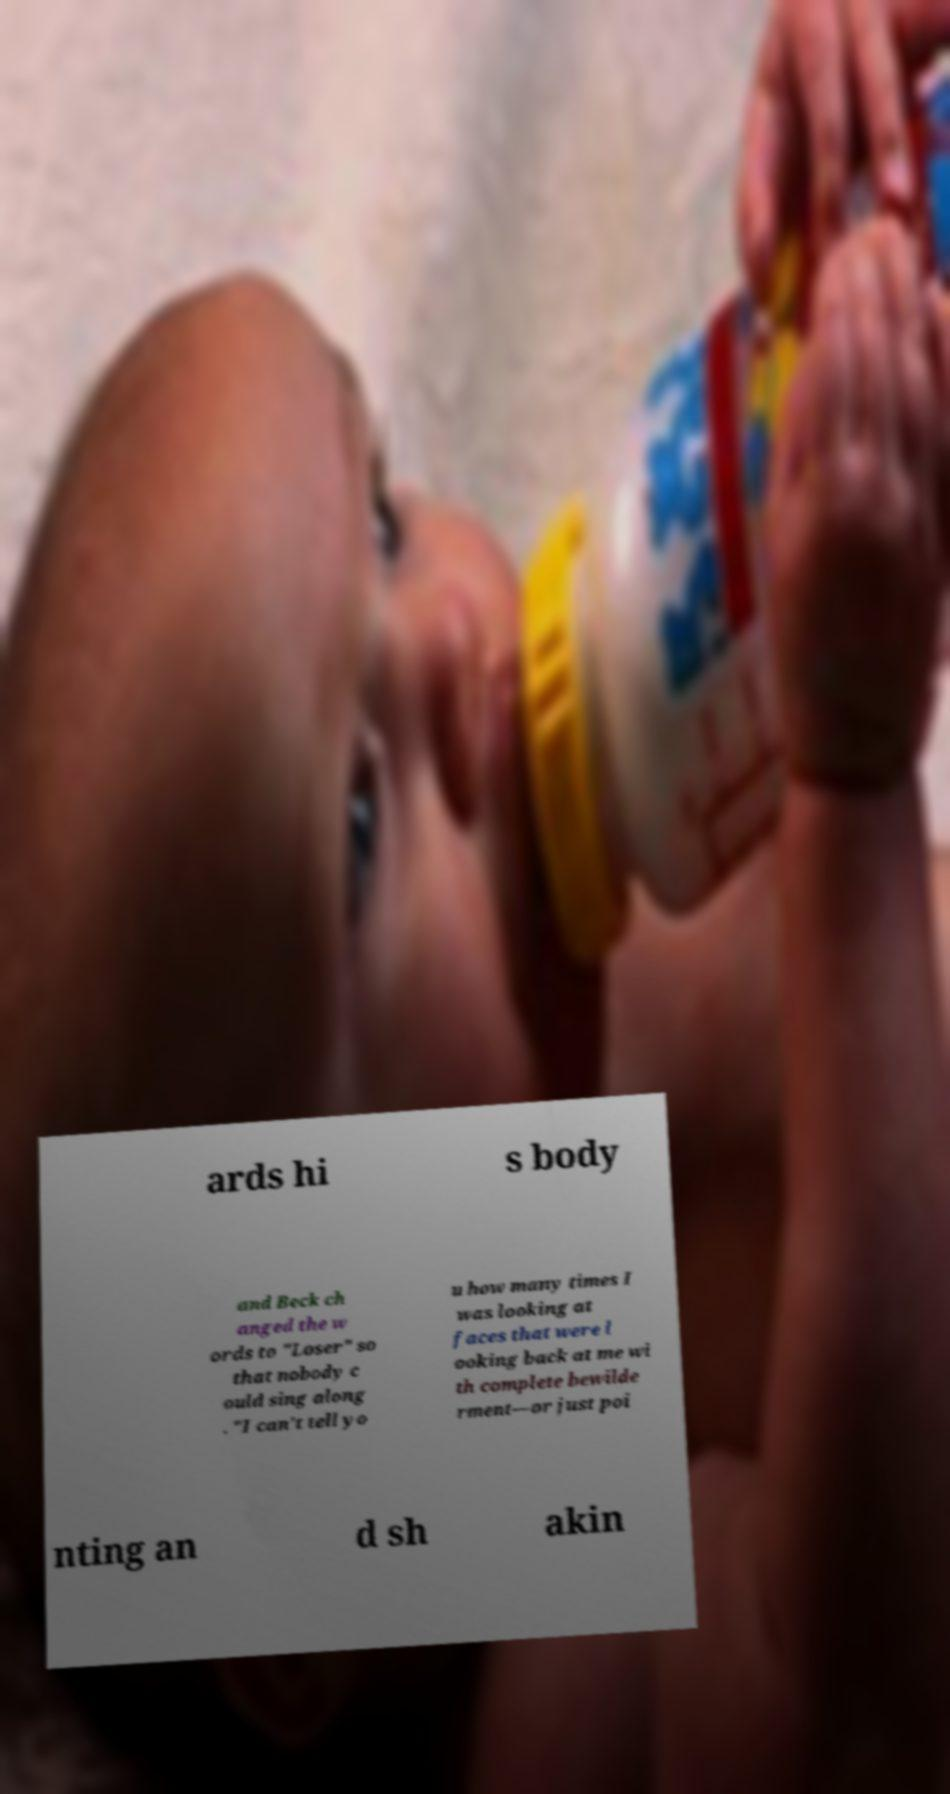Could you extract and type out the text from this image? ards hi s body and Beck ch anged the w ords to "Loser" so that nobody c ould sing along . "I can't tell yo u how many times I was looking at faces that were l ooking back at me wi th complete bewilde rment—or just poi nting an d sh akin 